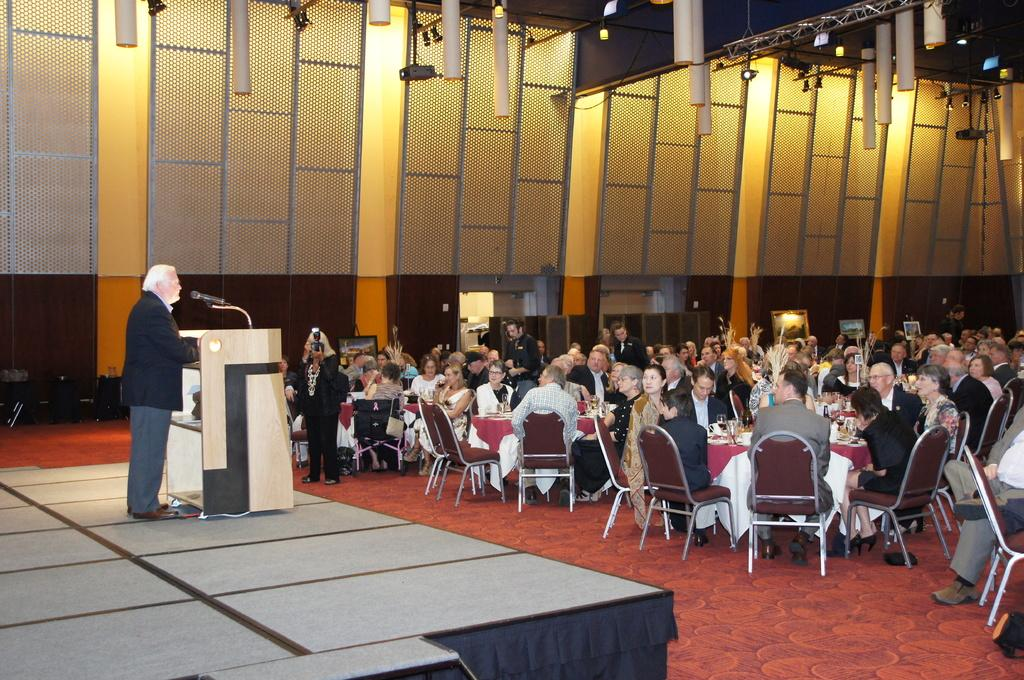What are the people in the image doing? There is a group of people sitting on chairs, suggesting they might be attending an event or meeting. Can you describe the man in the image? There is a man standing in the image, possibly as a speaker or presenter. What is the purpose of the podium and microphone in the image? The podium and microphone suggest that the man might be giving a speech or presentation. What can be seen in the background of the image? There is a carpet and files visible in the background. What else is present in the image? There are bags in the image. Can you tell me how many birds are sitting on the man's shoulder in the image? There are no birds present in the image. What type of glove is the man wearing while standing at the podium? The man is not wearing any gloves in the image. 